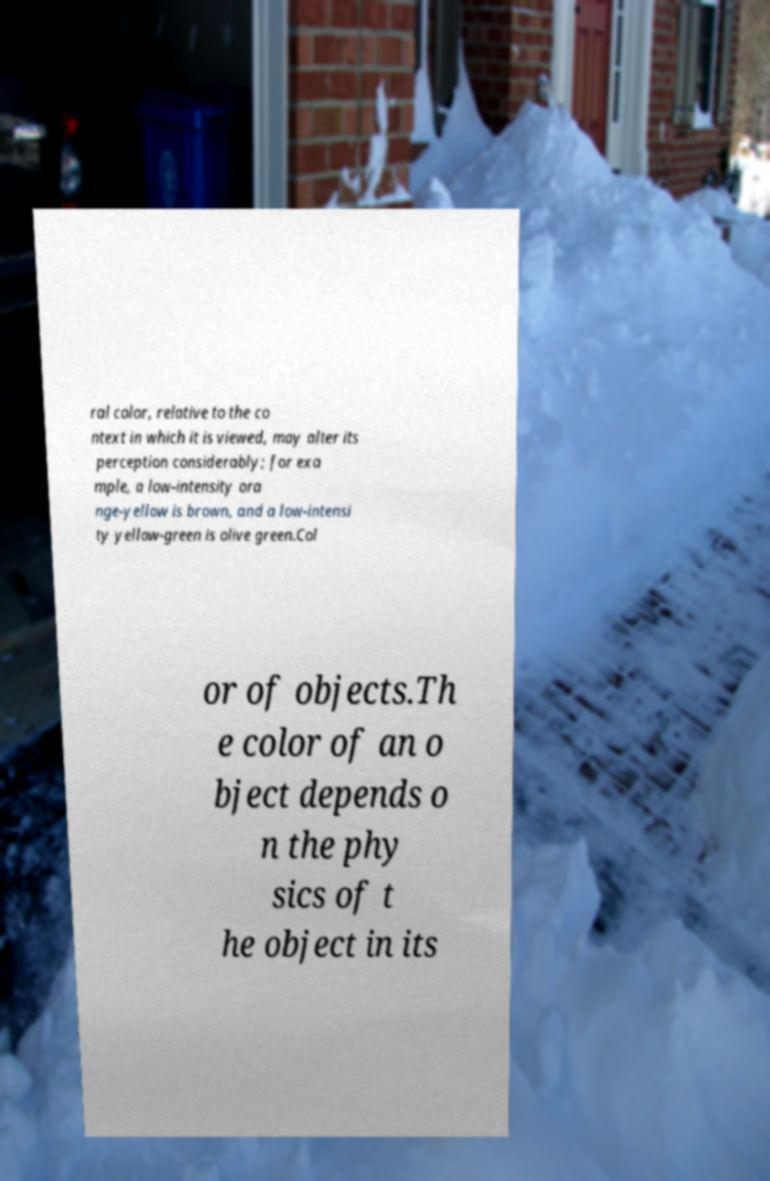There's text embedded in this image that I need extracted. Can you transcribe it verbatim? ral color, relative to the co ntext in which it is viewed, may alter its perception considerably; for exa mple, a low-intensity ora nge-yellow is brown, and a low-intensi ty yellow-green is olive green.Col or of objects.Th e color of an o bject depends o n the phy sics of t he object in its 